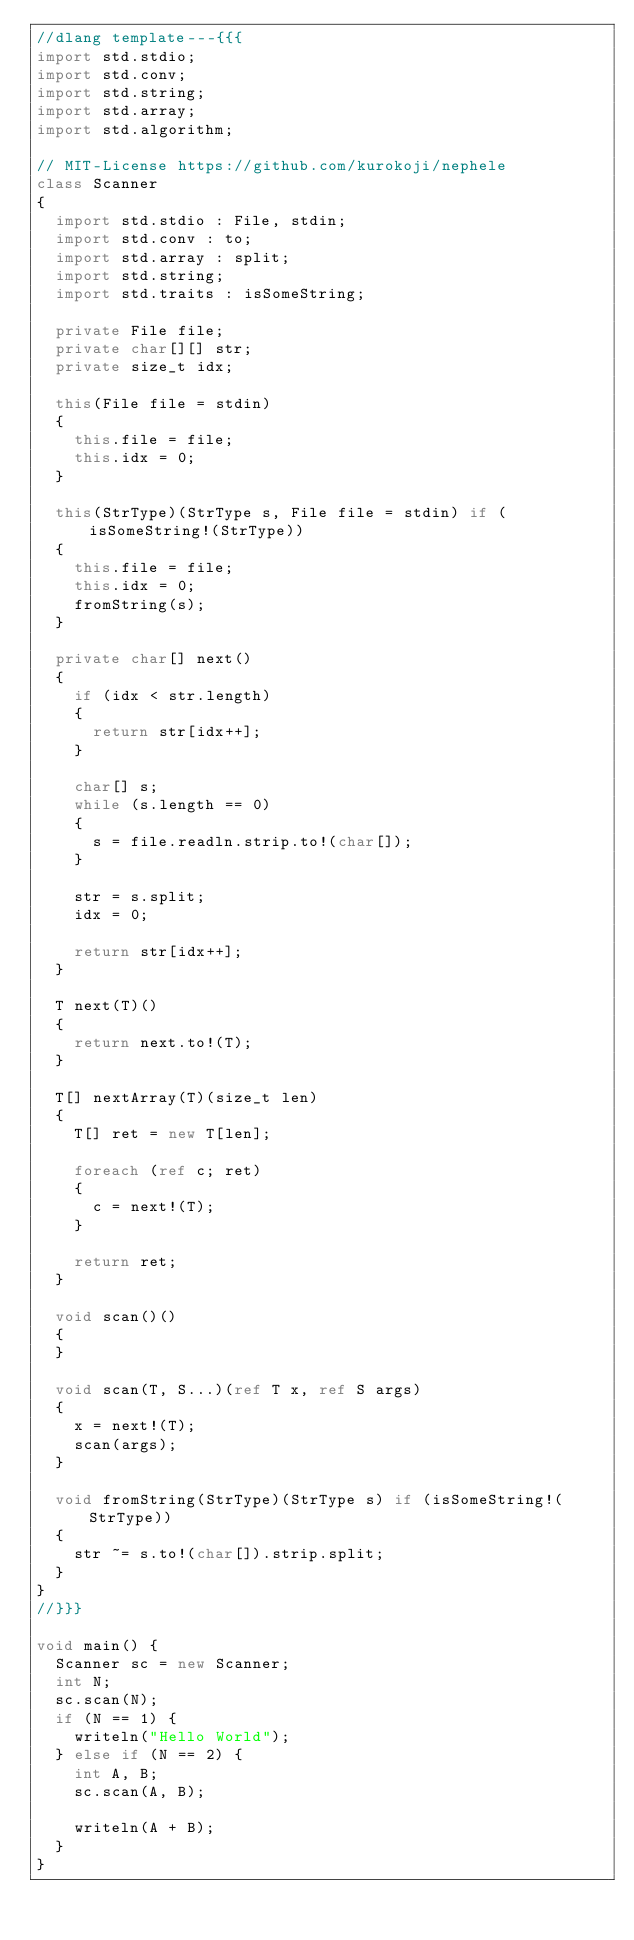Convert code to text. <code><loc_0><loc_0><loc_500><loc_500><_D_>//dlang template---{{{
import std.stdio;
import std.conv;
import std.string;
import std.array;
import std.algorithm;

// MIT-License https://github.com/kurokoji/nephele
class Scanner
{
  import std.stdio : File, stdin;
  import std.conv : to;
  import std.array : split;
  import std.string;
  import std.traits : isSomeString;

  private File file;
  private char[][] str;
  private size_t idx;

  this(File file = stdin)
  {
    this.file = file;
    this.idx = 0;
  }

  this(StrType)(StrType s, File file = stdin) if (isSomeString!(StrType))
  {
    this.file = file;
    this.idx = 0;
    fromString(s);
  }

  private char[] next()
  {
    if (idx < str.length)
    {
      return str[idx++];
    }

    char[] s;
    while (s.length == 0)
    {
      s = file.readln.strip.to!(char[]);
    }

    str = s.split;
    idx = 0;

    return str[idx++];
  }

  T next(T)()
  {
    return next.to!(T);
  }

  T[] nextArray(T)(size_t len)
  {
    T[] ret = new T[len];

    foreach (ref c; ret)
    {
      c = next!(T);
    }

    return ret;
  }

  void scan()()
  {
  }

  void scan(T, S...)(ref T x, ref S args)
  {
    x = next!(T);
    scan(args);
  }

  void fromString(StrType)(StrType s) if (isSomeString!(StrType))
  {
    str ~= s.to!(char[]).strip.split;
  }
}
//}}}

void main() {
  Scanner sc = new Scanner;
  int N;
  sc.scan(N);
  if (N == 1) {
    writeln("Hello World");
  } else if (N == 2) {
    int A, B;
    sc.scan(A, B);

    writeln(A + B);
  }
}
</code> 